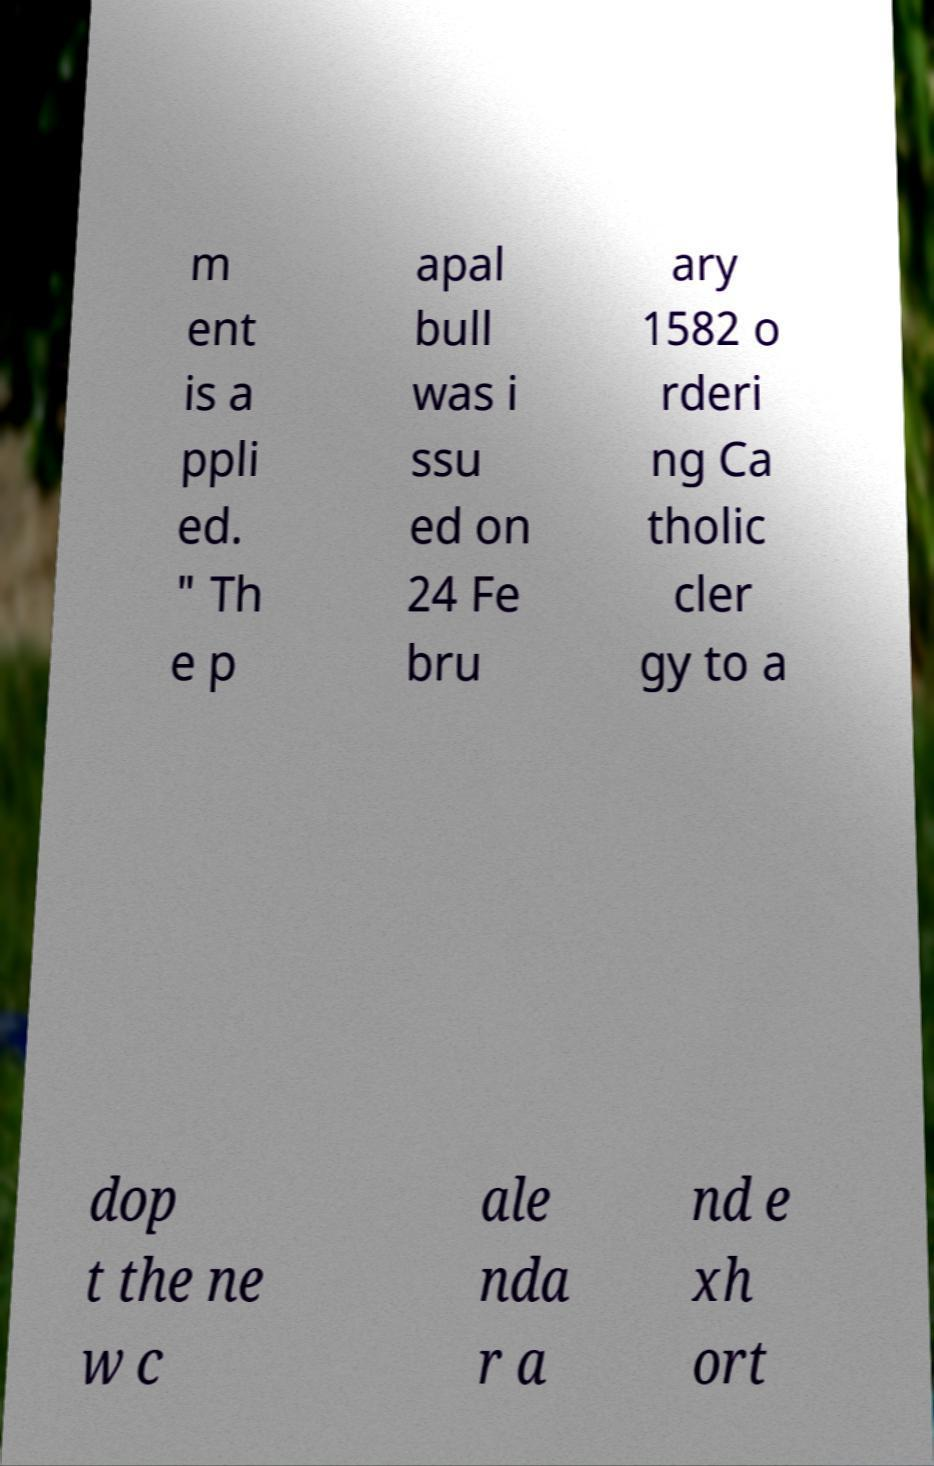Could you assist in decoding the text presented in this image and type it out clearly? m ent is a ppli ed. " Th e p apal bull was i ssu ed on 24 Fe bru ary 1582 o rderi ng Ca tholic cler gy to a dop t the ne w c ale nda r a nd e xh ort 